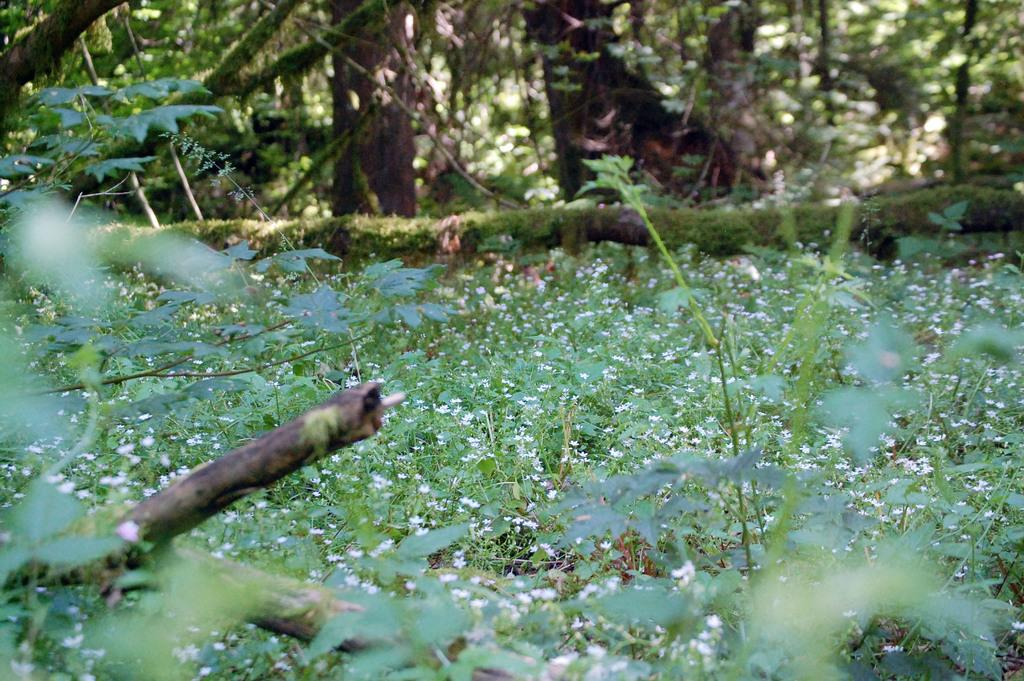What type of vegetation can be seen in the image? There are flowers on the plants and trees visible in the image. Can you describe the trees in the image? The trees are visible in the image, but no specific details about their appearance are provided. What color is the tooth on the tree in the image? There is no tooth present on the tree in the image. How many mailboxes are visible in the image? There is no mailbox present in the image. 